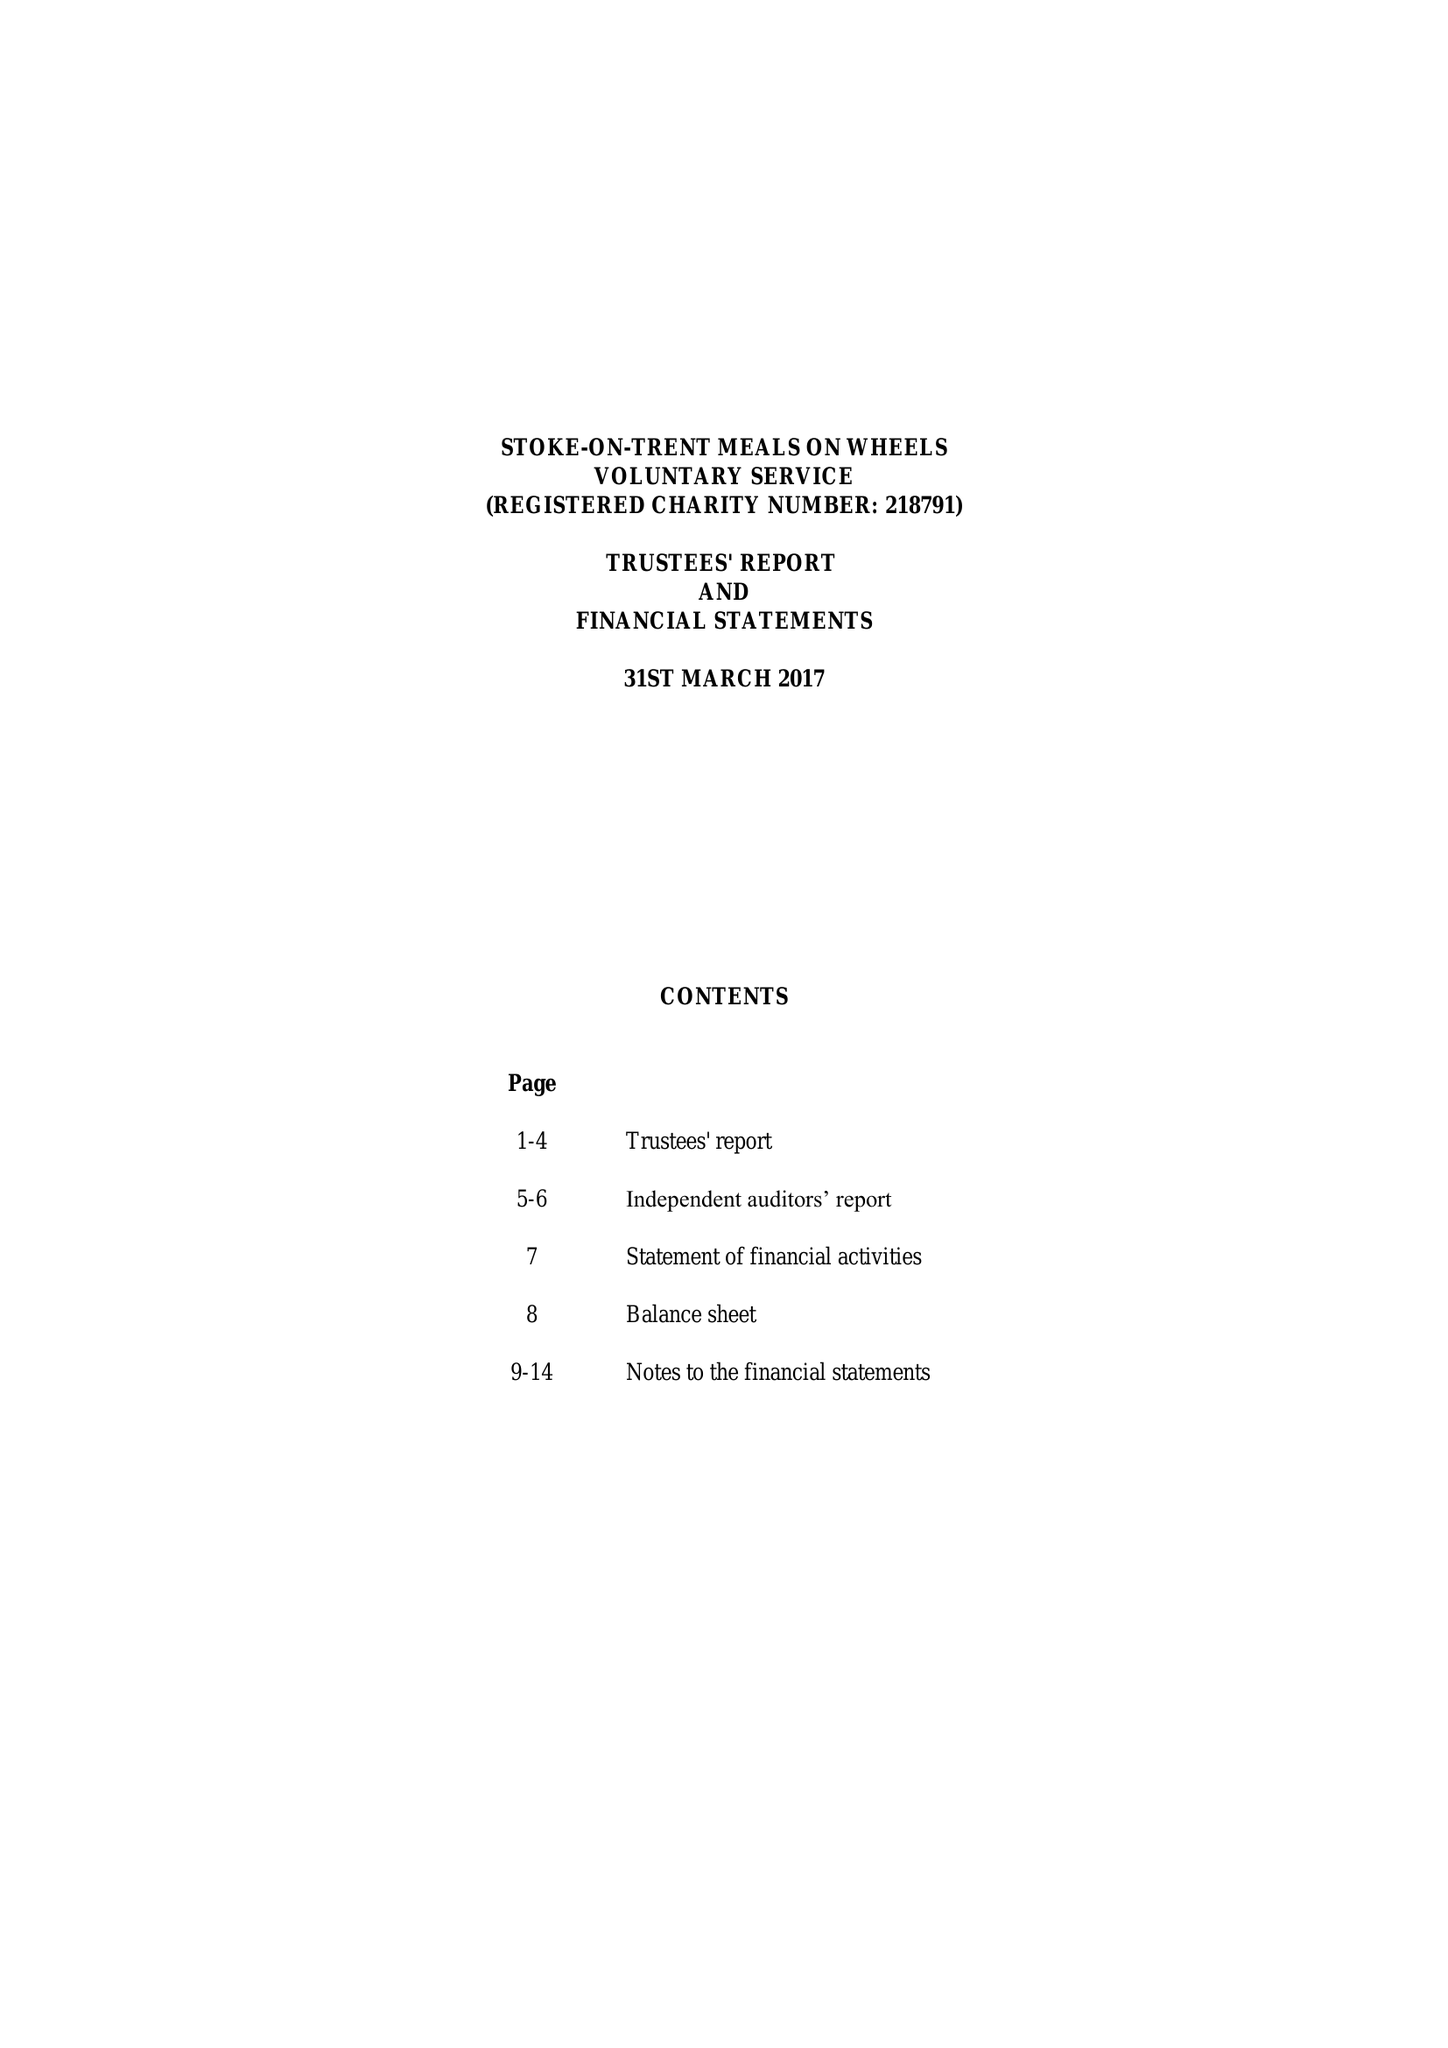What is the value for the income_annually_in_british_pounds?
Answer the question using a single word or phrase. 105907.00 